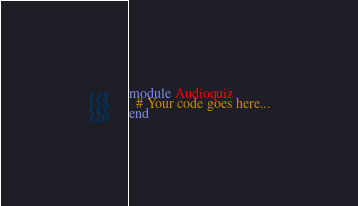<code> <loc_0><loc_0><loc_500><loc_500><_Ruby_>module Audioquiz
  # Your code goes here...
end
</code> 